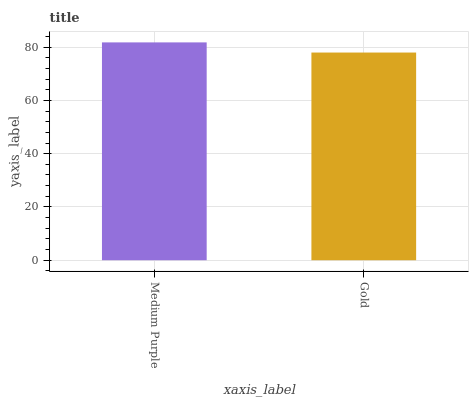Is Gold the minimum?
Answer yes or no. Yes. Is Medium Purple the maximum?
Answer yes or no. Yes. Is Gold the maximum?
Answer yes or no. No. Is Medium Purple greater than Gold?
Answer yes or no. Yes. Is Gold less than Medium Purple?
Answer yes or no. Yes. Is Gold greater than Medium Purple?
Answer yes or no. No. Is Medium Purple less than Gold?
Answer yes or no. No. Is Medium Purple the high median?
Answer yes or no. Yes. Is Gold the low median?
Answer yes or no. Yes. Is Gold the high median?
Answer yes or no. No. Is Medium Purple the low median?
Answer yes or no. No. 